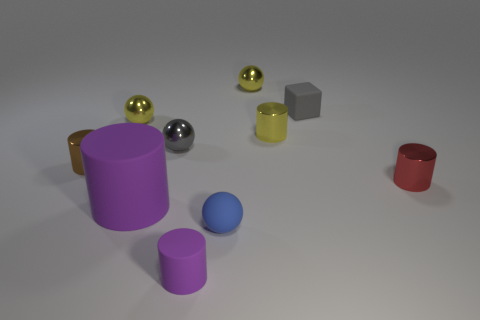Are there the same number of small gray matte blocks that are in front of the small blue matte ball and small cyan cylinders?
Ensure brevity in your answer.  Yes. Is there another red object that has the same shape as the big rubber thing?
Offer a terse response. Yes. What is the shape of the tiny thing that is both to the right of the tiny purple rubber cylinder and in front of the big cylinder?
Keep it short and to the point. Sphere. Is the material of the large purple thing the same as the sphere that is in front of the tiny red thing?
Ensure brevity in your answer.  Yes. Are there any matte things behind the blue matte thing?
Your response must be concise. Yes. What number of objects are either yellow things or small metallic balls to the right of the matte sphere?
Give a very brief answer. 3. There is a small metal cylinder that is on the left side of the purple thing that is in front of the tiny blue thing; what color is it?
Offer a very short reply. Brown. How many other things are there of the same material as the tiny cube?
Ensure brevity in your answer.  3. What number of matte objects are either purple cylinders or tiny gray balls?
Your answer should be compact. 2. There is a big matte object that is the same shape as the brown metal object; what color is it?
Make the answer very short. Purple. 